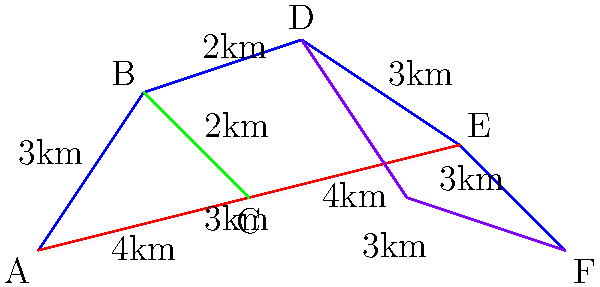A trail runner wants to find the most efficient path from point A to point F in the given trail network. The distances between connected points are shown in kilometers. What is the length of the shortest path from A to F? To solve this optimization problem, we need to consider all possible paths from A to F and calculate their total distances. Let's break it down step-by-step:

1. Identify all possible paths:
   Path 1: A -> B -> D -> E -> F
   Path 2: A -> B -> C -> E -> F
   Path 3: A -> C -> E -> F
   Path 4: A -> C -> B -> D -> E -> F

2. Calculate the distance for each path:
   Path 1: 3 + 2 + 3 + 3 = 11 km
   Path 2: 3 + 2 + 4 + 3 = 12 km
   Path 3: 4 + 4 + 3 = 11 km
   Path 4: 4 + 2 + 2 + 3 + 3 = 14 km

3. Compare the distances:
   The shortest paths are Path 1 and Path 3, both with a distance of 11 km.

4. Verify that there are no other shorter paths:
   We've considered all possible combinations using the given trail network, so we can be confident that 11 km is the shortest possible distance.

Therefore, the length of the shortest path from A to F is 11 km.
Answer: 11 km 